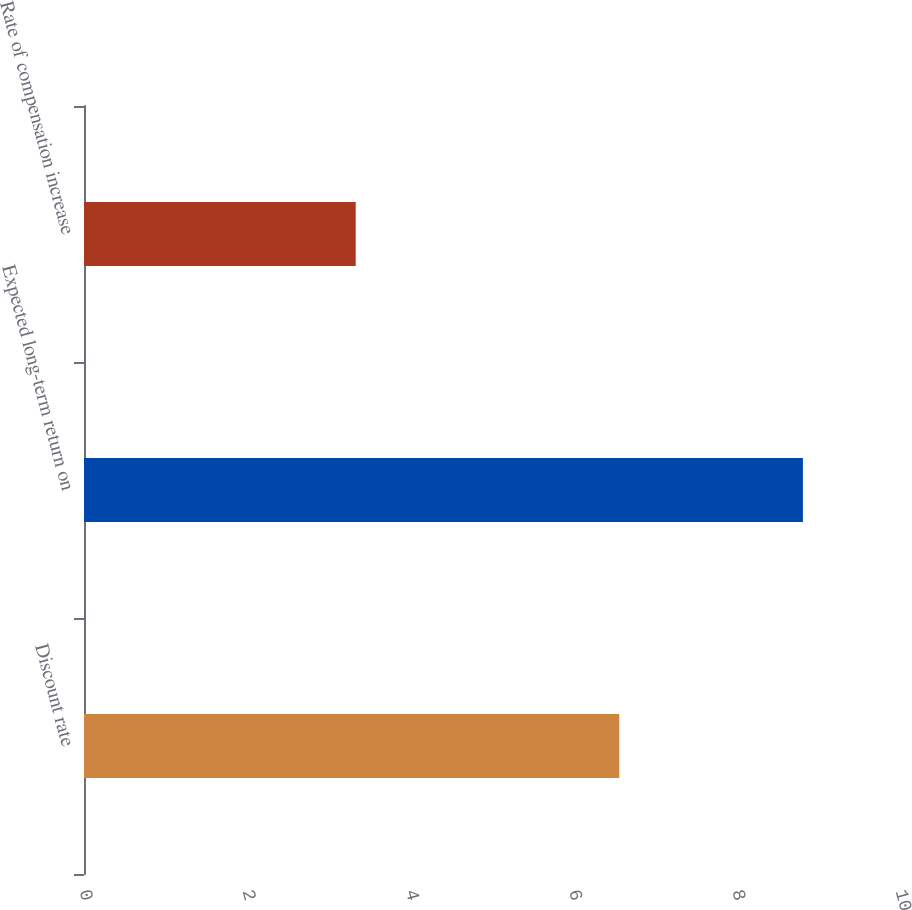<chart> <loc_0><loc_0><loc_500><loc_500><bar_chart><fcel>Discount rate<fcel>Expected long-term return on<fcel>Rate of compensation increase<nl><fcel>6.56<fcel>8.81<fcel>3.33<nl></chart> 